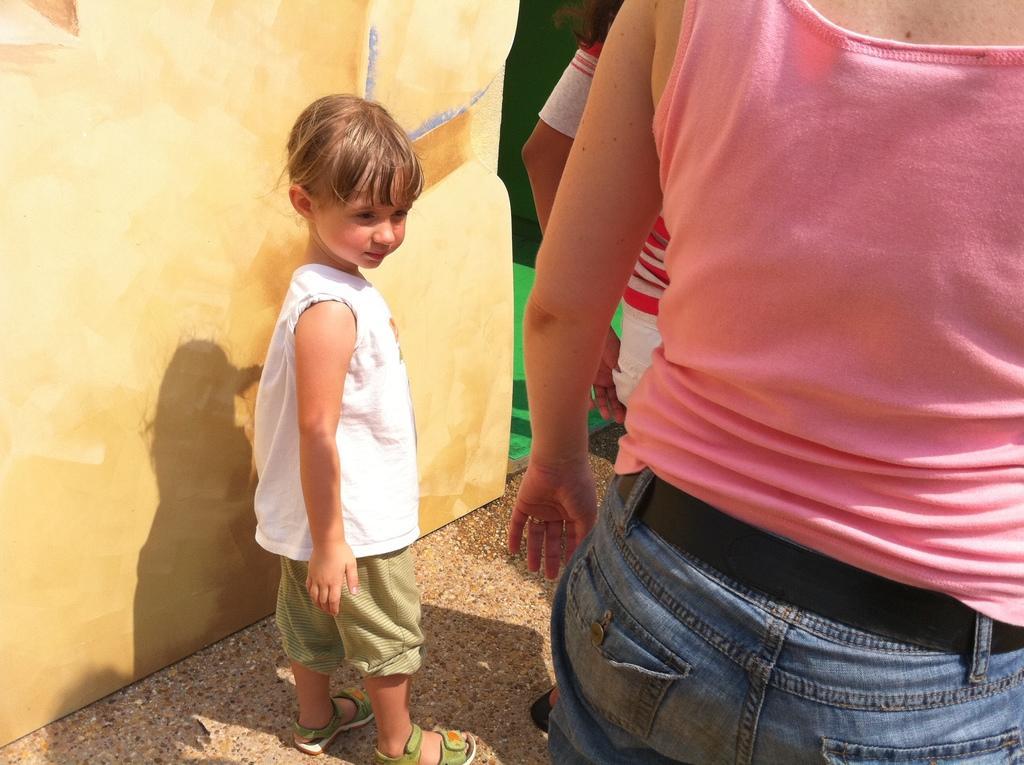Describe this image in one or two sentences. In this image we can see two people standing on the right side. A kid standing on the left side. And we can see the shadow. There is a wall and the green color carpet on the left side. 